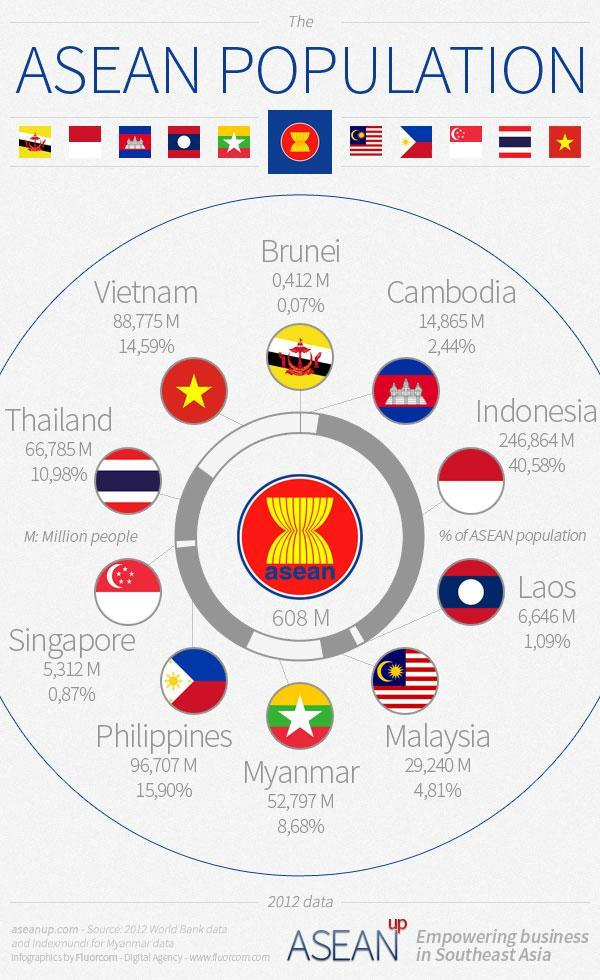Which country has the lowest percent of ASEAN population?
Answer the question with a short phrase. Brunei Which among these ASEAN countries has the higher population - Cambodia, Laos or Singapore? Cambodia Which country has 10.98% of ASEAN population? Thailand What is the population of Malaysia (in millions)? 29,240 M Which ASEAN country has a population of  88,775 million? Vietnam Which country has the highest percent of ASEAN population? Indonesia Which ASEAN country has a population of  96,707 million? Philippines Which country has 40.58% of ASEAN population? Indonesia How many countries have lower than 1% of ASEAN population? 2 Which country has 1.09% of ASEAN population? Laos 